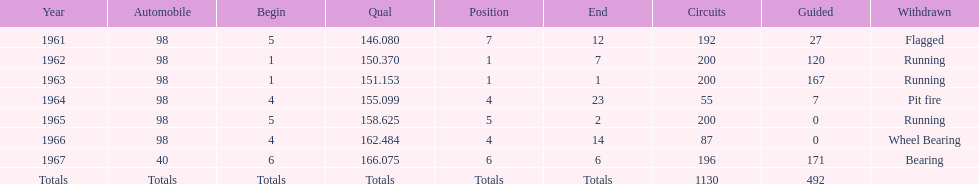What car achieved the highest qual? 40. Can you parse all the data within this table? {'header': ['Year', 'Automobile', 'Begin', 'Qual', 'Position', 'End', 'Circuits', 'Guided', 'Withdrawn'], 'rows': [['1961', '98', '5', '146.080', '7', '12', '192', '27', 'Flagged'], ['1962', '98', '1', '150.370', '1', '7', '200', '120', 'Running'], ['1963', '98', '1', '151.153', '1', '1', '200', '167', 'Running'], ['1964', '98', '4', '155.099', '4', '23', '55', '7', 'Pit fire'], ['1965', '98', '5', '158.625', '5', '2', '200', '0', 'Running'], ['1966', '98', '4', '162.484', '4', '14', '87', '0', 'Wheel Bearing'], ['1967', '40', '6', '166.075', '6', '6', '196', '171', 'Bearing'], ['Totals', 'Totals', 'Totals', 'Totals', 'Totals', 'Totals', '1130', '492', '']]} 